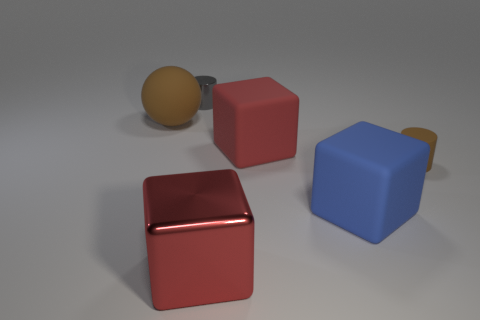Do the gray cylinder and the brown rubber cylinder have the same size?
Your response must be concise. Yes. Do the brown object right of the tiny gray cylinder and the tiny gray thing have the same material?
Your answer should be very brief. No. How many red cubes are on the right side of the metallic thing that is in front of the brown sphere that is in front of the metal cylinder?
Your answer should be very brief. 1. Is the shape of the metallic object on the right side of the gray metallic thing the same as  the red rubber object?
Provide a succinct answer. Yes. How many objects are large balls or cylinders in front of the small gray thing?
Make the answer very short. 2. Are there more large red cubes in front of the blue rubber block than small yellow cubes?
Offer a very short reply. Yes. Are there the same number of tiny brown matte objects on the left side of the large blue matte object and matte blocks right of the large metal cube?
Your answer should be very brief. No. There is a small thing in front of the big matte sphere; are there any things in front of it?
Provide a succinct answer. Yes. What is the shape of the small metallic object?
Offer a very short reply. Cylinder. What is the size of the rubber object that is the same color as the tiny rubber cylinder?
Make the answer very short. Large. 